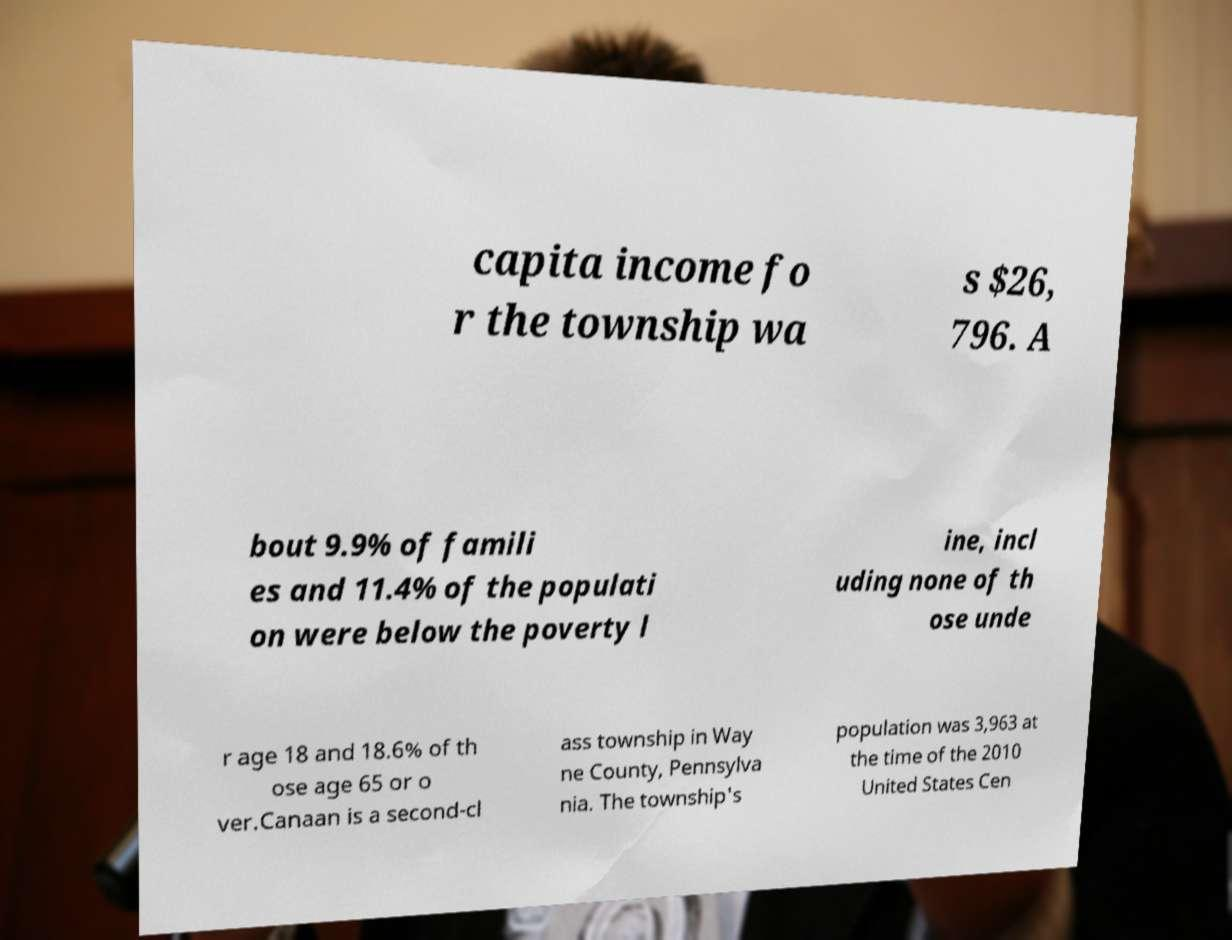Please identify and transcribe the text found in this image. capita income fo r the township wa s $26, 796. A bout 9.9% of famili es and 11.4% of the populati on were below the poverty l ine, incl uding none of th ose unde r age 18 and 18.6% of th ose age 65 or o ver.Canaan is a second-cl ass township in Way ne County, Pennsylva nia. The township's population was 3,963 at the time of the 2010 United States Cen 